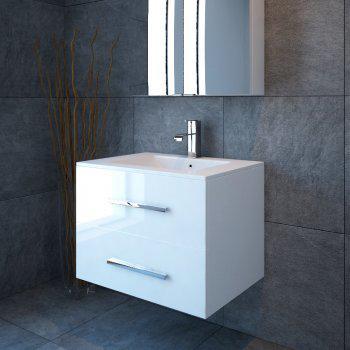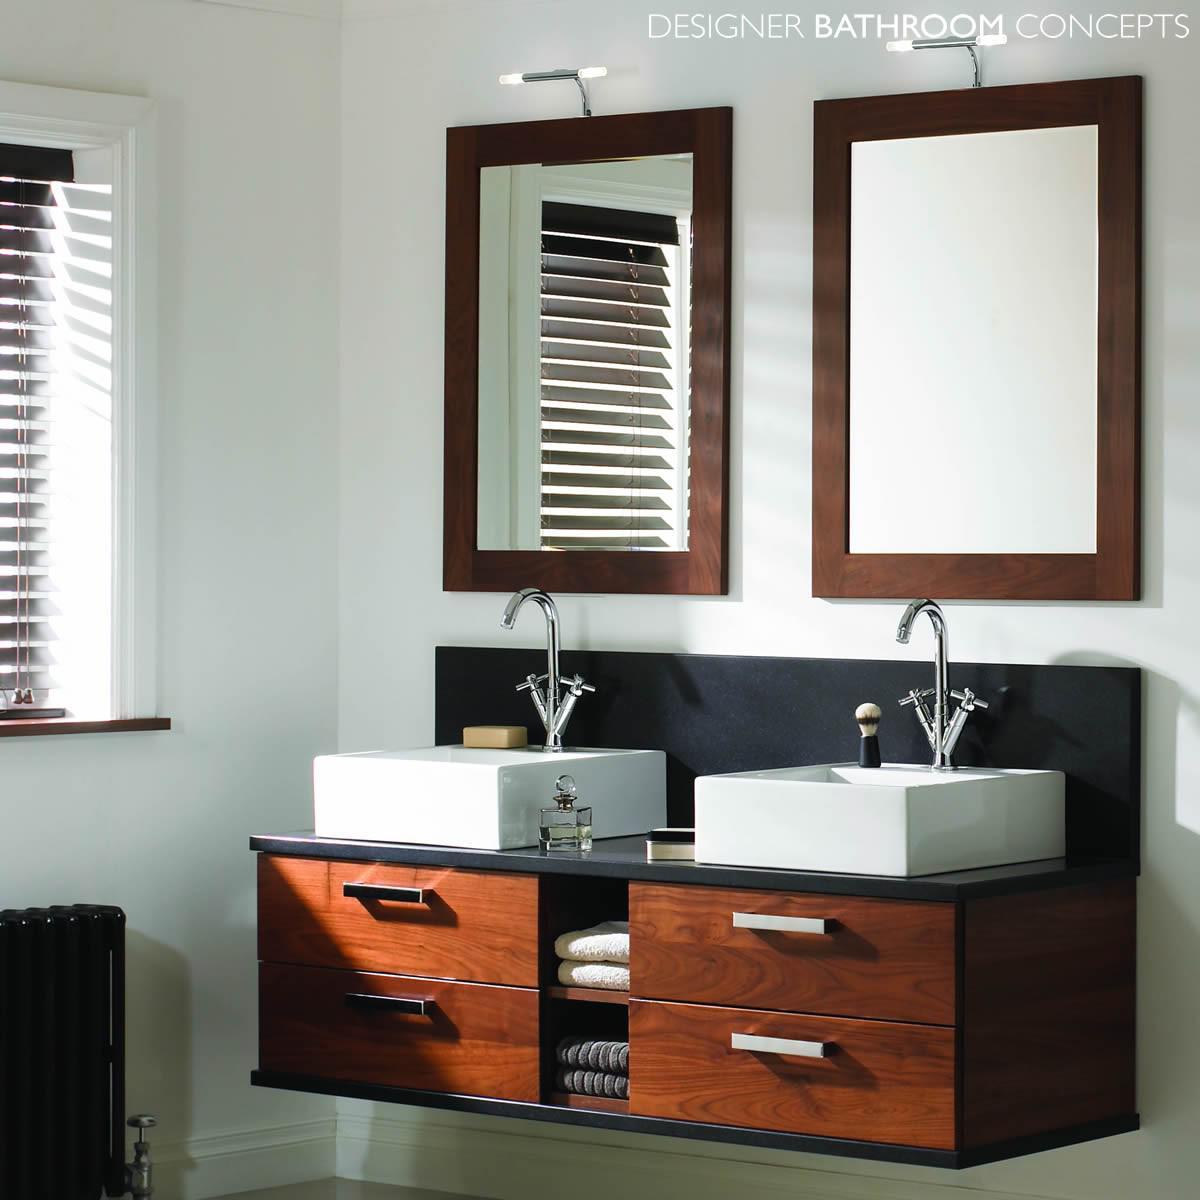The first image is the image on the left, the second image is the image on the right. Evaluate the accuracy of this statement regarding the images: "At least one of the sinks has a floral arrangement next to it.". Is it true? Answer yes or no. No. 